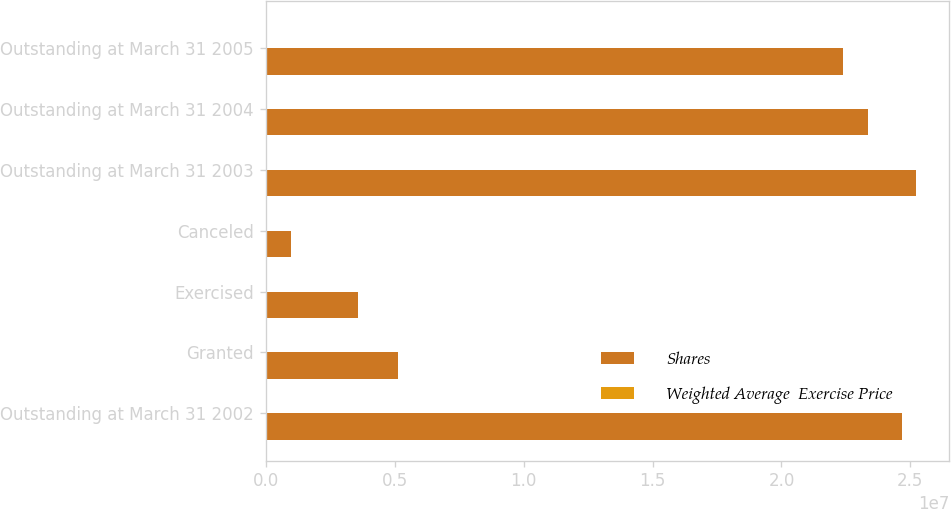Convert chart. <chart><loc_0><loc_0><loc_500><loc_500><stacked_bar_chart><ecel><fcel>Outstanding at March 31 2002<fcel>Granted<fcel>Exercised<fcel>Canceled<fcel>Outstanding at March 31 2003<fcel>Outstanding at March 31 2004<fcel>Outstanding at March 31 2005<nl><fcel>Shares<fcel>2.46668e+07<fcel>5.1269e+06<fcel>3.5649e+06<fcel>993899<fcel>2.52349e+07<fcel>2.33599e+07<fcel>2.23707e+07<nl><fcel>Weighted Average  Exercise Price<fcel>12.12<fcel>25.76<fcel>6.47<fcel>18.11<fcel>15.45<fcel>17.6<fcel>19.19<nl></chart> 